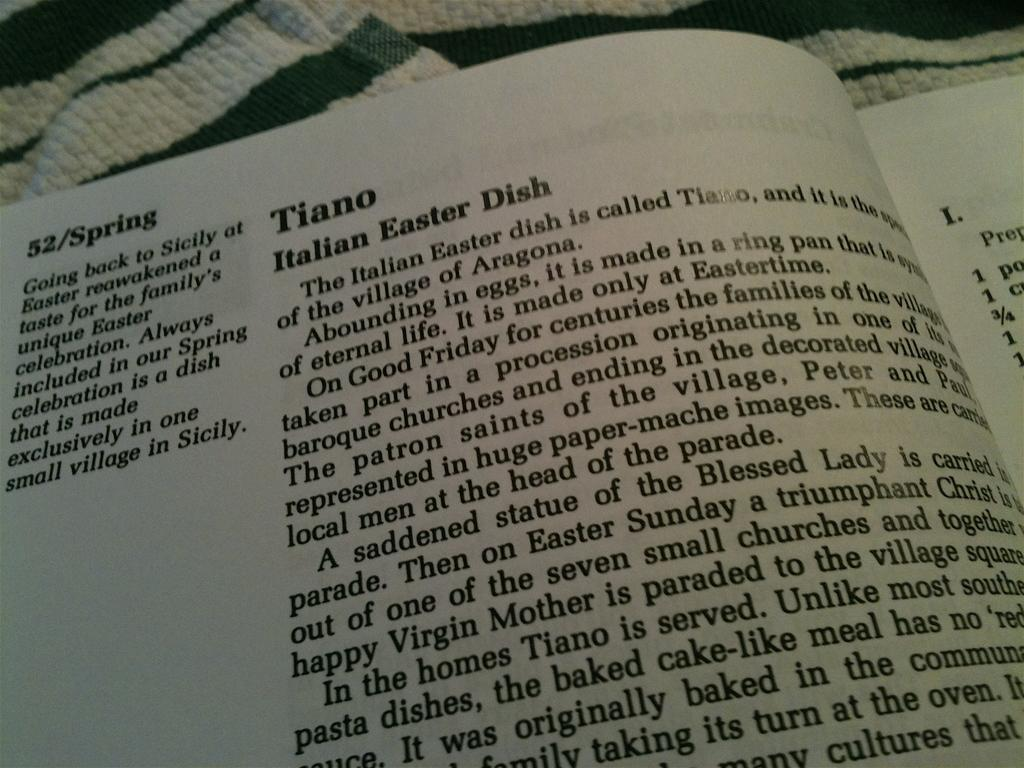<image>
Describe the image concisely. A page of a book describing an Italian Easter dish 